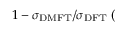<formula> <loc_0><loc_0><loc_500><loc_500>1 - \sigma _ { D M F T } / \sigma _ { D F T } ( \</formula> 